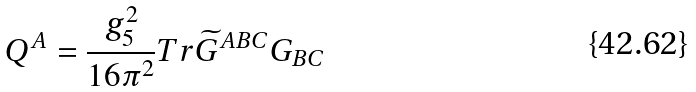Convert formula to latex. <formula><loc_0><loc_0><loc_500><loc_500>Q ^ { A } = \frac { g _ { 5 } ^ { 2 } } { 1 6 \pi ^ { 2 } } T r \widetilde { G } ^ { A B C } G _ { B C }</formula> 